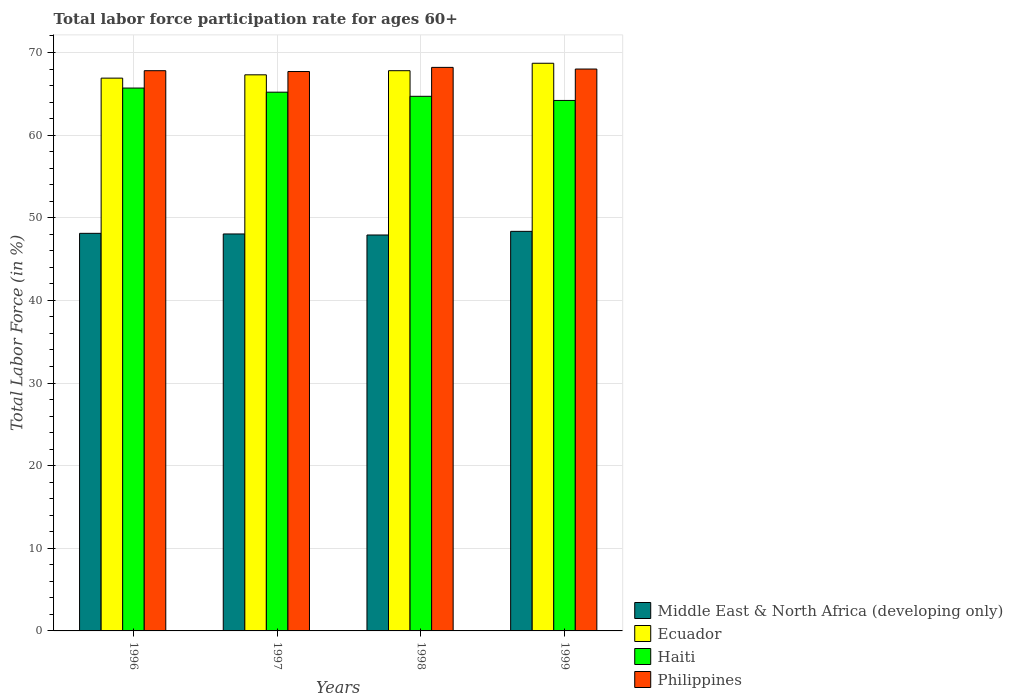How many different coloured bars are there?
Provide a succinct answer. 4. How many groups of bars are there?
Provide a succinct answer. 4. How many bars are there on the 3rd tick from the left?
Keep it short and to the point. 4. Across all years, what is the maximum labor force participation rate in Philippines?
Offer a terse response. 68.2. Across all years, what is the minimum labor force participation rate in Haiti?
Make the answer very short. 64.2. In which year was the labor force participation rate in Haiti minimum?
Offer a terse response. 1999. What is the total labor force participation rate in Haiti in the graph?
Give a very brief answer. 259.8. What is the difference between the labor force participation rate in Ecuador in 1997 and that in 1999?
Keep it short and to the point. -1.4. What is the difference between the labor force participation rate in Ecuador in 1998 and the labor force participation rate in Philippines in 1997?
Keep it short and to the point. 0.1. What is the average labor force participation rate in Ecuador per year?
Make the answer very short. 67.68. In the year 1999, what is the difference between the labor force participation rate in Haiti and labor force participation rate in Philippines?
Ensure brevity in your answer.  -3.8. What is the ratio of the labor force participation rate in Ecuador in 1997 to that in 1999?
Ensure brevity in your answer.  0.98. Is the labor force participation rate in Middle East & North Africa (developing only) in 1996 less than that in 1999?
Keep it short and to the point. Yes. What is the difference between the highest and the second highest labor force participation rate in Philippines?
Provide a short and direct response. 0.2. What is the difference between the highest and the lowest labor force participation rate in Middle East & North Africa (developing only)?
Make the answer very short. 0.44. In how many years, is the labor force participation rate in Middle East & North Africa (developing only) greater than the average labor force participation rate in Middle East & North Africa (developing only) taken over all years?
Offer a very short reply. 2. Is the sum of the labor force participation rate in Philippines in 1996 and 1999 greater than the maximum labor force participation rate in Haiti across all years?
Make the answer very short. Yes. Is it the case that in every year, the sum of the labor force participation rate in Ecuador and labor force participation rate in Philippines is greater than the sum of labor force participation rate in Middle East & North Africa (developing only) and labor force participation rate in Haiti?
Give a very brief answer. No. What does the 3rd bar from the left in 1997 represents?
Keep it short and to the point. Haiti. What does the 3rd bar from the right in 1997 represents?
Your answer should be very brief. Ecuador. Is it the case that in every year, the sum of the labor force participation rate in Philippines and labor force participation rate in Ecuador is greater than the labor force participation rate in Haiti?
Offer a terse response. Yes. How many years are there in the graph?
Ensure brevity in your answer.  4. Are the values on the major ticks of Y-axis written in scientific E-notation?
Offer a very short reply. No. How are the legend labels stacked?
Keep it short and to the point. Vertical. What is the title of the graph?
Give a very brief answer. Total labor force participation rate for ages 60+. Does "Costa Rica" appear as one of the legend labels in the graph?
Your response must be concise. No. What is the label or title of the X-axis?
Offer a terse response. Years. What is the label or title of the Y-axis?
Your answer should be compact. Total Labor Force (in %). What is the Total Labor Force (in %) of Middle East & North Africa (developing only) in 1996?
Your answer should be compact. 48.12. What is the Total Labor Force (in %) of Ecuador in 1996?
Keep it short and to the point. 66.9. What is the Total Labor Force (in %) in Haiti in 1996?
Give a very brief answer. 65.7. What is the Total Labor Force (in %) of Philippines in 1996?
Make the answer very short. 67.8. What is the Total Labor Force (in %) in Middle East & North Africa (developing only) in 1997?
Offer a very short reply. 48.04. What is the Total Labor Force (in %) of Ecuador in 1997?
Keep it short and to the point. 67.3. What is the Total Labor Force (in %) of Haiti in 1997?
Make the answer very short. 65.2. What is the Total Labor Force (in %) of Philippines in 1997?
Keep it short and to the point. 67.7. What is the Total Labor Force (in %) of Middle East & North Africa (developing only) in 1998?
Your response must be concise. 47.92. What is the Total Labor Force (in %) in Ecuador in 1998?
Your answer should be very brief. 67.8. What is the Total Labor Force (in %) in Haiti in 1998?
Your answer should be compact. 64.7. What is the Total Labor Force (in %) in Philippines in 1998?
Provide a succinct answer. 68.2. What is the Total Labor Force (in %) of Middle East & North Africa (developing only) in 1999?
Provide a succinct answer. 48.36. What is the Total Labor Force (in %) in Ecuador in 1999?
Provide a short and direct response. 68.7. What is the Total Labor Force (in %) of Haiti in 1999?
Ensure brevity in your answer.  64.2. Across all years, what is the maximum Total Labor Force (in %) of Middle East & North Africa (developing only)?
Ensure brevity in your answer.  48.36. Across all years, what is the maximum Total Labor Force (in %) in Ecuador?
Provide a succinct answer. 68.7. Across all years, what is the maximum Total Labor Force (in %) of Haiti?
Keep it short and to the point. 65.7. Across all years, what is the maximum Total Labor Force (in %) in Philippines?
Your answer should be very brief. 68.2. Across all years, what is the minimum Total Labor Force (in %) of Middle East & North Africa (developing only)?
Your answer should be very brief. 47.92. Across all years, what is the minimum Total Labor Force (in %) in Ecuador?
Give a very brief answer. 66.9. Across all years, what is the minimum Total Labor Force (in %) of Haiti?
Keep it short and to the point. 64.2. Across all years, what is the minimum Total Labor Force (in %) of Philippines?
Offer a terse response. 67.7. What is the total Total Labor Force (in %) of Middle East & North Africa (developing only) in the graph?
Keep it short and to the point. 192.43. What is the total Total Labor Force (in %) of Ecuador in the graph?
Ensure brevity in your answer.  270.7. What is the total Total Labor Force (in %) of Haiti in the graph?
Your answer should be compact. 259.8. What is the total Total Labor Force (in %) in Philippines in the graph?
Offer a very short reply. 271.7. What is the difference between the Total Labor Force (in %) of Middle East & North Africa (developing only) in 1996 and that in 1997?
Ensure brevity in your answer.  0.08. What is the difference between the Total Labor Force (in %) of Philippines in 1996 and that in 1997?
Ensure brevity in your answer.  0.1. What is the difference between the Total Labor Force (in %) in Middle East & North Africa (developing only) in 1996 and that in 1998?
Ensure brevity in your answer.  0.2. What is the difference between the Total Labor Force (in %) in Philippines in 1996 and that in 1998?
Offer a terse response. -0.4. What is the difference between the Total Labor Force (in %) in Middle East & North Africa (developing only) in 1996 and that in 1999?
Your answer should be very brief. -0.24. What is the difference between the Total Labor Force (in %) in Philippines in 1996 and that in 1999?
Offer a terse response. -0.2. What is the difference between the Total Labor Force (in %) of Middle East & North Africa (developing only) in 1997 and that in 1998?
Provide a succinct answer. 0.12. What is the difference between the Total Labor Force (in %) in Philippines in 1997 and that in 1998?
Keep it short and to the point. -0.5. What is the difference between the Total Labor Force (in %) of Middle East & North Africa (developing only) in 1997 and that in 1999?
Offer a very short reply. -0.32. What is the difference between the Total Labor Force (in %) of Haiti in 1997 and that in 1999?
Your answer should be very brief. 1. What is the difference between the Total Labor Force (in %) in Philippines in 1997 and that in 1999?
Make the answer very short. -0.3. What is the difference between the Total Labor Force (in %) in Middle East & North Africa (developing only) in 1998 and that in 1999?
Offer a terse response. -0.44. What is the difference between the Total Labor Force (in %) in Ecuador in 1998 and that in 1999?
Provide a succinct answer. -0.9. What is the difference between the Total Labor Force (in %) in Middle East & North Africa (developing only) in 1996 and the Total Labor Force (in %) in Ecuador in 1997?
Your answer should be compact. -19.18. What is the difference between the Total Labor Force (in %) in Middle East & North Africa (developing only) in 1996 and the Total Labor Force (in %) in Haiti in 1997?
Your answer should be compact. -17.08. What is the difference between the Total Labor Force (in %) of Middle East & North Africa (developing only) in 1996 and the Total Labor Force (in %) of Philippines in 1997?
Provide a short and direct response. -19.58. What is the difference between the Total Labor Force (in %) of Ecuador in 1996 and the Total Labor Force (in %) of Philippines in 1997?
Offer a terse response. -0.8. What is the difference between the Total Labor Force (in %) of Middle East & North Africa (developing only) in 1996 and the Total Labor Force (in %) of Ecuador in 1998?
Provide a short and direct response. -19.68. What is the difference between the Total Labor Force (in %) in Middle East & North Africa (developing only) in 1996 and the Total Labor Force (in %) in Haiti in 1998?
Offer a terse response. -16.58. What is the difference between the Total Labor Force (in %) in Middle East & North Africa (developing only) in 1996 and the Total Labor Force (in %) in Philippines in 1998?
Your answer should be compact. -20.08. What is the difference between the Total Labor Force (in %) of Ecuador in 1996 and the Total Labor Force (in %) of Haiti in 1998?
Keep it short and to the point. 2.2. What is the difference between the Total Labor Force (in %) of Ecuador in 1996 and the Total Labor Force (in %) of Philippines in 1998?
Your answer should be compact. -1.3. What is the difference between the Total Labor Force (in %) in Middle East & North Africa (developing only) in 1996 and the Total Labor Force (in %) in Ecuador in 1999?
Provide a succinct answer. -20.58. What is the difference between the Total Labor Force (in %) of Middle East & North Africa (developing only) in 1996 and the Total Labor Force (in %) of Haiti in 1999?
Ensure brevity in your answer.  -16.08. What is the difference between the Total Labor Force (in %) in Middle East & North Africa (developing only) in 1996 and the Total Labor Force (in %) in Philippines in 1999?
Offer a terse response. -19.88. What is the difference between the Total Labor Force (in %) of Ecuador in 1996 and the Total Labor Force (in %) of Haiti in 1999?
Your answer should be very brief. 2.7. What is the difference between the Total Labor Force (in %) of Haiti in 1996 and the Total Labor Force (in %) of Philippines in 1999?
Your answer should be very brief. -2.3. What is the difference between the Total Labor Force (in %) of Middle East & North Africa (developing only) in 1997 and the Total Labor Force (in %) of Ecuador in 1998?
Your answer should be very brief. -19.76. What is the difference between the Total Labor Force (in %) of Middle East & North Africa (developing only) in 1997 and the Total Labor Force (in %) of Haiti in 1998?
Make the answer very short. -16.66. What is the difference between the Total Labor Force (in %) of Middle East & North Africa (developing only) in 1997 and the Total Labor Force (in %) of Philippines in 1998?
Your response must be concise. -20.16. What is the difference between the Total Labor Force (in %) in Ecuador in 1997 and the Total Labor Force (in %) in Haiti in 1998?
Provide a succinct answer. 2.6. What is the difference between the Total Labor Force (in %) of Ecuador in 1997 and the Total Labor Force (in %) of Philippines in 1998?
Your answer should be compact. -0.9. What is the difference between the Total Labor Force (in %) of Middle East & North Africa (developing only) in 1997 and the Total Labor Force (in %) of Ecuador in 1999?
Ensure brevity in your answer.  -20.66. What is the difference between the Total Labor Force (in %) of Middle East & North Africa (developing only) in 1997 and the Total Labor Force (in %) of Haiti in 1999?
Provide a succinct answer. -16.16. What is the difference between the Total Labor Force (in %) of Middle East & North Africa (developing only) in 1997 and the Total Labor Force (in %) of Philippines in 1999?
Your answer should be compact. -19.96. What is the difference between the Total Labor Force (in %) in Ecuador in 1997 and the Total Labor Force (in %) in Haiti in 1999?
Ensure brevity in your answer.  3.1. What is the difference between the Total Labor Force (in %) of Ecuador in 1997 and the Total Labor Force (in %) of Philippines in 1999?
Your answer should be very brief. -0.7. What is the difference between the Total Labor Force (in %) of Middle East & North Africa (developing only) in 1998 and the Total Labor Force (in %) of Ecuador in 1999?
Your answer should be compact. -20.78. What is the difference between the Total Labor Force (in %) in Middle East & North Africa (developing only) in 1998 and the Total Labor Force (in %) in Haiti in 1999?
Ensure brevity in your answer.  -16.28. What is the difference between the Total Labor Force (in %) in Middle East & North Africa (developing only) in 1998 and the Total Labor Force (in %) in Philippines in 1999?
Your response must be concise. -20.08. What is the difference between the Total Labor Force (in %) of Ecuador in 1998 and the Total Labor Force (in %) of Haiti in 1999?
Your answer should be very brief. 3.6. What is the difference between the Total Labor Force (in %) of Haiti in 1998 and the Total Labor Force (in %) of Philippines in 1999?
Your answer should be compact. -3.3. What is the average Total Labor Force (in %) in Middle East & North Africa (developing only) per year?
Provide a short and direct response. 48.11. What is the average Total Labor Force (in %) in Ecuador per year?
Provide a succinct answer. 67.67. What is the average Total Labor Force (in %) of Haiti per year?
Provide a short and direct response. 64.95. What is the average Total Labor Force (in %) in Philippines per year?
Your answer should be compact. 67.92. In the year 1996, what is the difference between the Total Labor Force (in %) of Middle East & North Africa (developing only) and Total Labor Force (in %) of Ecuador?
Offer a very short reply. -18.78. In the year 1996, what is the difference between the Total Labor Force (in %) of Middle East & North Africa (developing only) and Total Labor Force (in %) of Haiti?
Your response must be concise. -17.58. In the year 1996, what is the difference between the Total Labor Force (in %) in Middle East & North Africa (developing only) and Total Labor Force (in %) in Philippines?
Offer a very short reply. -19.68. In the year 1997, what is the difference between the Total Labor Force (in %) in Middle East & North Africa (developing only) and Total Labor Force (in %) in Ecuador?
Your response must be concise. -19.26. In the year 1997, what is the difference between the Total Labor Force (in %) in Middle East & North Africa (developing only) and Total Labor Force (in %) in Haiti?
Offer a very short reply. -17.16. In the year 1997, what is the difference between the Total Labor Force (in %) of Middle East & North Africa (developing only) and Total Labor Force (in %) of Philippines?
Keep it short and to the point. -19.66. In the year 1998, what is the difference between the Total Labor Force (in %) in Middle East & North Africa (developing only) and Total Labor Force (in %) in Ecuador?
Offer a terse response. -19.88. In the year 1998, what is the difference between the Total Labor Force (in %) in Middle East & North Africa (developing only) and Total Labor Force (in %) in Haiti?
Provide a succinct answer. -16.78. In the year 1998, what is the difference between the Total Labor Force (in %) in Middle East & North Africa (developing only) and Total Labor Force (in %) in Philippines?
Offer a terse response. -20.28. In the year 1998, what is the difference between the Total Labor Force (in %) in Haiti and Total Labor Force (in %) in Philippines?
Provide a succinct answer. -3.5. In the year 1999, what is the difference between the Total Labor Force (in %) of Middle East & North Africa (developing only) and Total Labor Force (in %) of Ecuador?
Offer a terse response. -20.34. In the year 1999, what is the difference between the Total Labor Force (in %) of Middle East & North Africa (developing only) and Total Labor Force (in %) of Haiti?
Keep it short and to the point. -15.84. In the year 1999, what is the difference between the Total Labor Force (in %) in Middle East & North Africa (developing only) and Total Labor Force (in %) in Philippines?
Provide a succinct answer. -19.64. In the year 1999, what is the difference between the Total Labor Force (in %) in Ecuador and Total Labor Force (in %) in Philippines?
Your answer should be very brief. 0.7. What is the ratio of the Total Labor Force (in %) of Ecuador in 1996 to that in 1997?
Your response must be concise. 0.99. What is the ratio of the Total Labor Force (in %) of Haiti in 1996 to that in 1997?
Your response must be concise. 1.01. What is the ratio of the Total Labor Force (in %) of Philippines in 1996 to that in 1997?
Offer a very short reply. 1. What is the ratio of the Total Labor Force (in %) of Middle East & North Africa (developing only) in 1996 to that in 1998?
Keep it short and to the point. 1. What is the ratio of the Total Labor Force (in %) of Ecuador in 1996 to that in 1998?
Give a very brief answer. 0.99. What is the ratio of the Total Labor Force (in %) in Haiti in 1996 to that in 1998?
Make the answer very short. 1.02. What is the ratio of the Total Labor Force (in %) of Philippines in 1996 to that in 1998?
Your answer should be compact. 0.99. What is the ratio of the Total Labor Force (in %) of Middle East & North Africa (developing only) in 1996 to that in 1999?
Ensure brevity in your answer.  0.99. What is the ratio of the Total Labor Force (in %) of Ecuador in 1996 to that in 1999?
Your answer should be compact. 0.97. What is the ratio of the Total Labor Force (in %) of Haiti in 1996 to that in 1999?
Give a very brief answer. 1.02. What is the ratio of the Total Labor Force (in %) in Philippines in 1996 to that in 1999?
Provide a short and direct response. 1. What is the ratio of the Total Labor Force (in %) in Middle East & North Africa (developing only) in 1997 to that in 1998?
Your answer should be very brief. 1. What is the ratio of the Total Labor Force (in %) of Ecuador in 1997 to that in 1998?
Your answer should be very brief. 0.99. What is the ratio of the Total Labor Force (in %) in Haiti in 1997 to that in 1998?
Make the answer very short. 1.01. What is the ratio of the Total Labor Force (in %) in Philippines in 1997 to that in 1998?
Ensure brevity in your answer.  0.99. What is the ratio of the Total Labor Force (in %) of Middle East & North Africa (developing only) in 1997 to that in 1999?
Provide a short and direct response. 0.99. What is the ratio of the Total Labor Force (in %) of Ecuador in 1997 to that in 1999?
Give a very brief answer. 0.98. What is the ratio of the Total Labor Force (in %) of Haiti in 1997 to that in 1999?
Offer a terse response. 1.02. What is the ratio of the Total Labor Force (in %) in Philippines in 1997 to that in 1999?
Make the answer very short. 1. What is the ratio of the Total Labor Force (in %) in Middle East & North Africa (developing only) in 1998 to that in 1999?
Your answer should be compact. 0.99. What is the ratio of the Total Labor Force (in %) of Ecuador in 1998 to that in 1999?
Ensure brevity in your answer.  0.99. What is the ratio of the Total Labor Force (in %) of Haiti in 1998 to that in 1999?
Keep it short and to the point. 1.01. What is the difference between the highest and the second highest Total Labor Force (in %) of Middle East & North Africa (developing only)?
Your answer should be compact. 0.24. What is the difference between the highest and the second highest Total Labor Force (in %) in Ecuador?
Offer a terse response. 0.9. What is the difference between the highest and the second highest Total Labor Force (in %) in Haiti?
Your response must be concise. 0.5. What is the difference between the highest and the second highest Total Labor Force (in %) in Philippines?
Your response must be concise. 0.2. What is the difference between the highest and the lowest Total Labor Force (in %) of Middle East & North Africa (developing only)?
Offer a very short reply. 0.44. What is the difference between the highest and the lowest Total Labor Force (in %) in Ecuador?
Your answer should be very brief. 1.8. What is the difference between the highest and the lowest Total Labor Force (in %) of Philippines?
Your response must be concise. 0.5. 